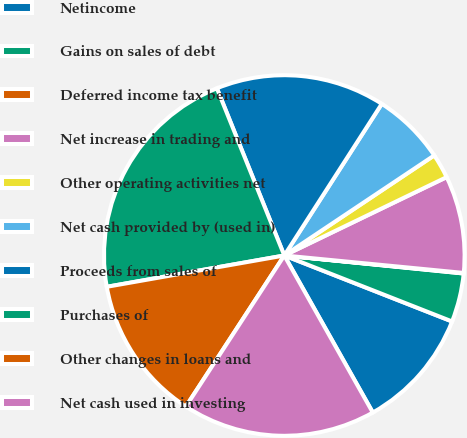Convert chart. <chart><loc_0><loc_0><loc_500><loc_500><pie_chart><fcel>Netincome<fcel>Gains on sales of debt<fcel>Deferred income tax benefit<fcel>Net increase in trading and<fcel>Other operating activities net<fcel>Net cash provided by (used in)<fcel>Proceeds from sales of<fcel>Purchases of<fcel>Other changes in loans and<fcel>Net cash used in investing<nl><fcel>10.87%<fcel>4.37%<fcel>0.05%<fcel>8.7%<fcel>2.21%<fcel>6.54%<fcel>15.19%<fcel>21.68%<fcel>13.03%<fcel>17.36%<nl></chart> 